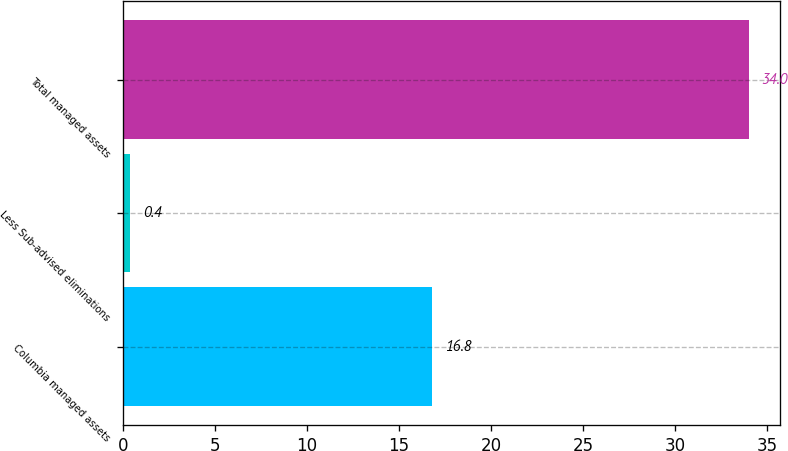Convert chart to OTSL. <chart><loc_0><loc_0><loc_500><loc_500><bar_chart><fcel>Columbia managed assets<fcel>Less Sub-advised eliminations<fcel>Total managed assets<nl><fcel>16.8<fcel>0.4<fcel>34<nl></chart> 